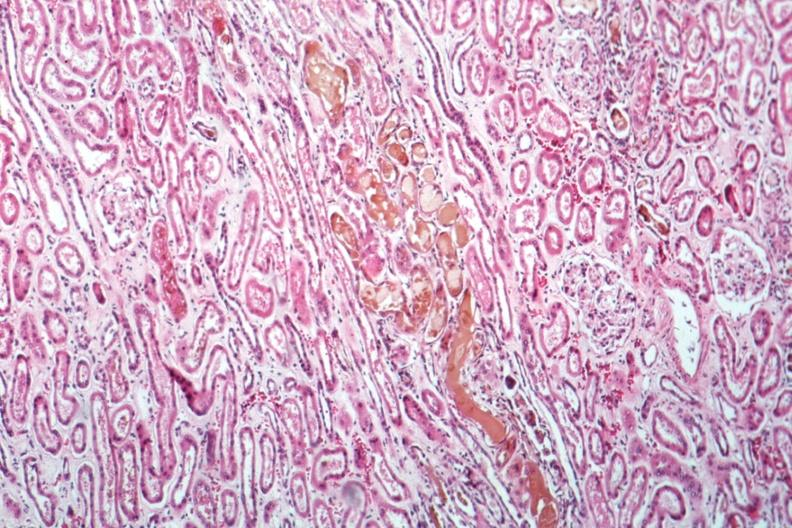what is present?
Answer the question using a single word or phrase. Kidney 